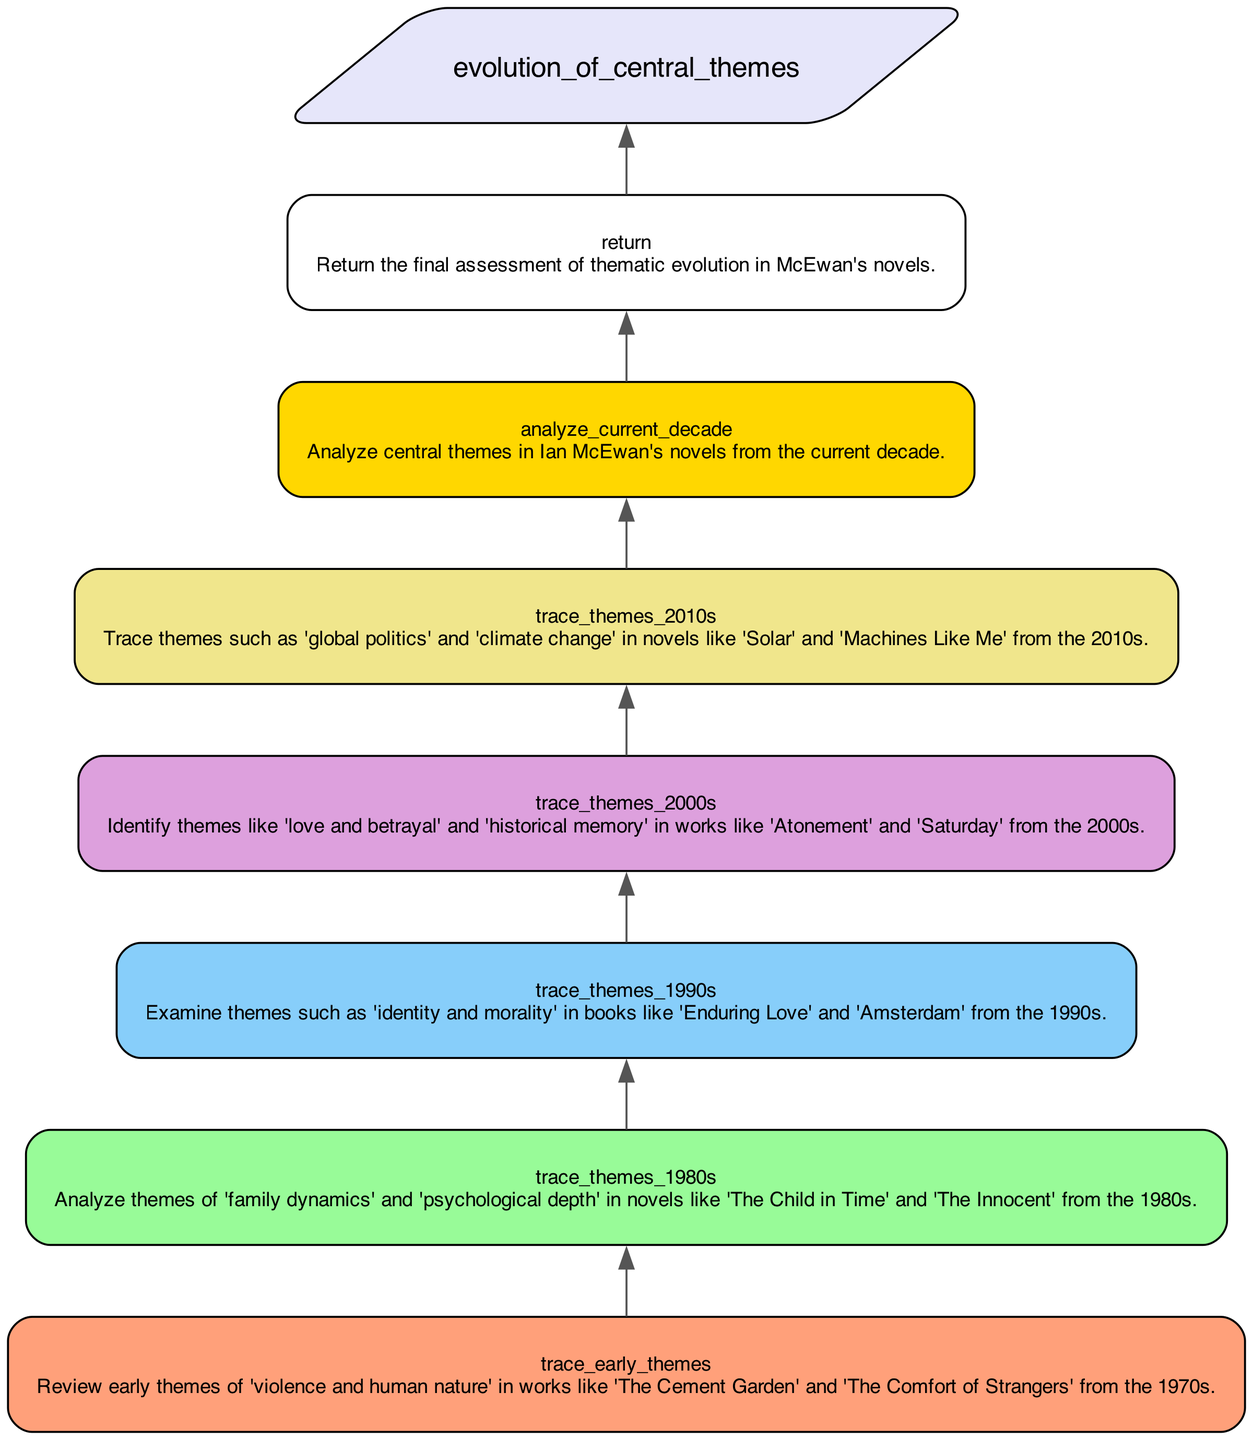What are the central themes analyzed in the current decade? The current decade's themes are analyzed in the step labeled "analyze_current_decade," which would encompass a contemporary evaluation of McEwan's works.
Answer: Central themes in current decade Which step examines themes from the 1990s? The step labeled "trace_themes_1990s" specifically addresses the themes from the 1990s, indicating which aspects of McEwan's writing from that era are explored.
Answer: trace_themes_1990s How many themes are traced for the 2000s? The diagram shows one step for tracing themes specific to the 2000s, labeled as "trace_themes_2000s." Since it is singular, this indicates that only one primary step is devoted to that decade.
Answer: One What relationships exist between the 1970s themes and the analysis of the 1980s themes? The flowchart indicates a progression from the step "trace_early_themes" for the 1970s, directly connecting to the step "trace_themes_1980s," suggesting that the themes of these decades are analyzed in succession, possibly to show evolving ideas over time.
Answer: Successive analysis Which decade has the theme 'global politics' identified? The theme 'global politics' is specifically traced in the 2010s, as described in the step "trace_themes_2010s." This ties that theme directly to the works of McEwan from that decade.
Answer: 2010s What is the final step in the diagram? The final step, which summarizes all preceding analytical processes and assessments, is explicitly noted as "return," concluding the workflow of thematic exploration in McEwan's novels.
Answer: return How does the flow of the diagram progress from themes of the 1980s to the current decade? The diagram flows from "trace_themes_1980s" up to "analyze_current_decade," indicating that the themes from the 1980s lead into an analysis of the current decade's themes. This represents a historical progression in thematic focus.
Answer: Historical progression What shape is used to denote the function name at the top of the diagram? The function name is presented in a parallelogram shape, distinguishing it visually from the other rectangular nodes that follow it.
Answer: Parallelogram 